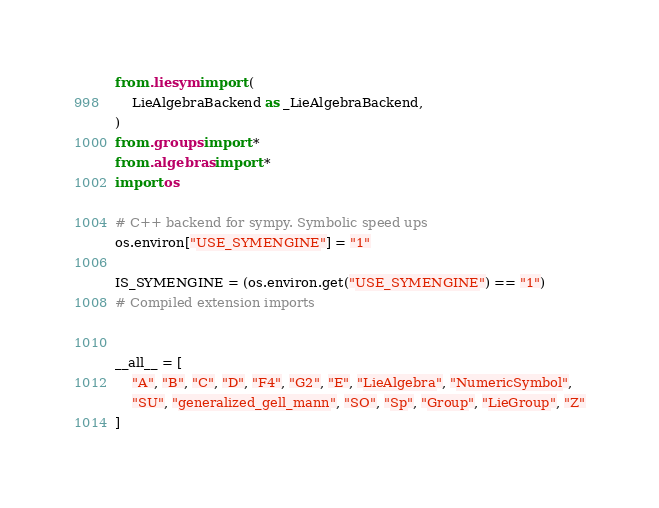<code> <loc_0><loc_0><loc_500><loc_500><_Python_>from .liesym import (
    LieAlgebraBackend as _LieAlgebraBackend,
)
from .groups import *
from .algebras import *
import os

# C++ backend for sympy. Symbolic speed ups
os.environ["USE_SYMENGINE"] = "1"

IS_SYMENGINE = (os.environ.get("USE_SYMENGINE") == "1")
# Compiled extension imports


__all__ = [
    "A", "B", "C", "D", "F4", "G2", "E", "LieAlgebra", "NumericSymbol",
    "SU", "generalized_gell_mann", "SO", "Sp", "Group", "LieGroup", "Z"
]
</code> 